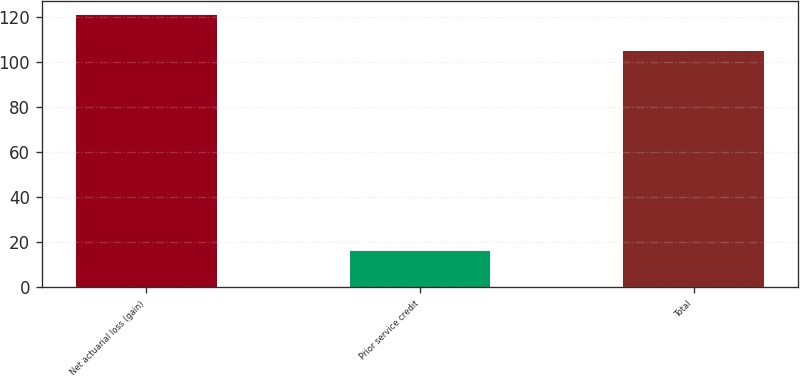<chart> <loc_0><loc_0><loc_500><loc_500><bar_chart><fcel>Net actuarial loss (gain)<fcel>Prior service credit<fcel>Total<nl><fcel>121<fcel>16<fcel>105<nl></chart> 